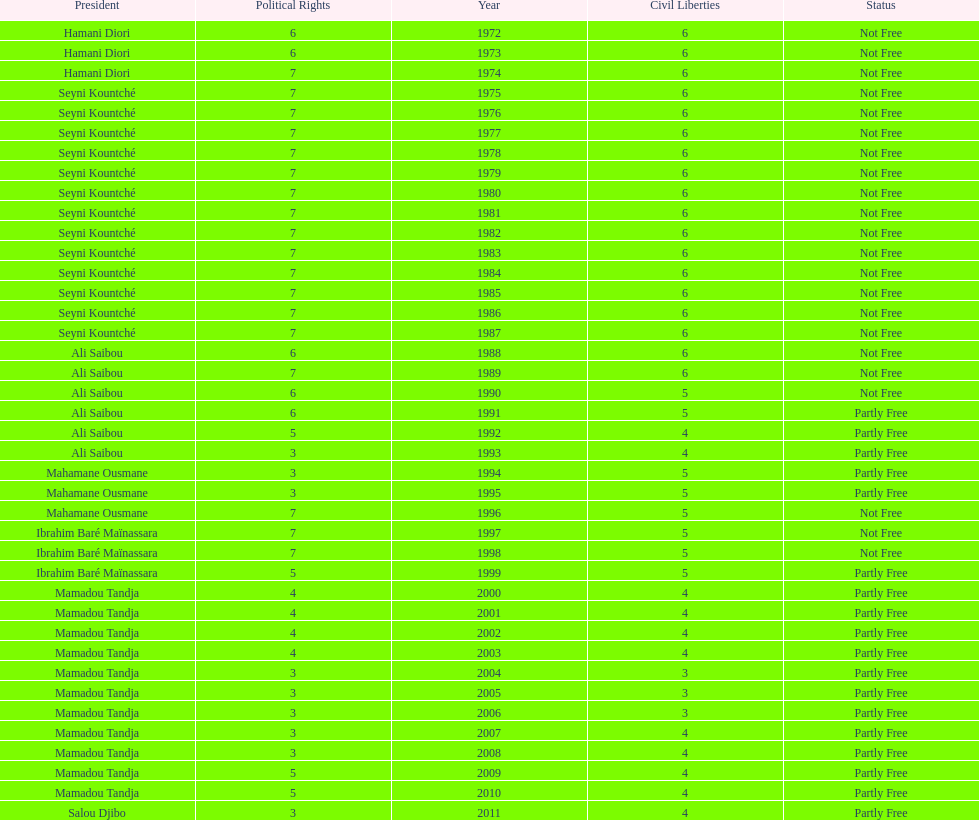How many years was it before the first partly free status? 18. 